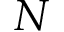<formula> <loc_0><loc_0><loc_500><loc_500>N</formula> 